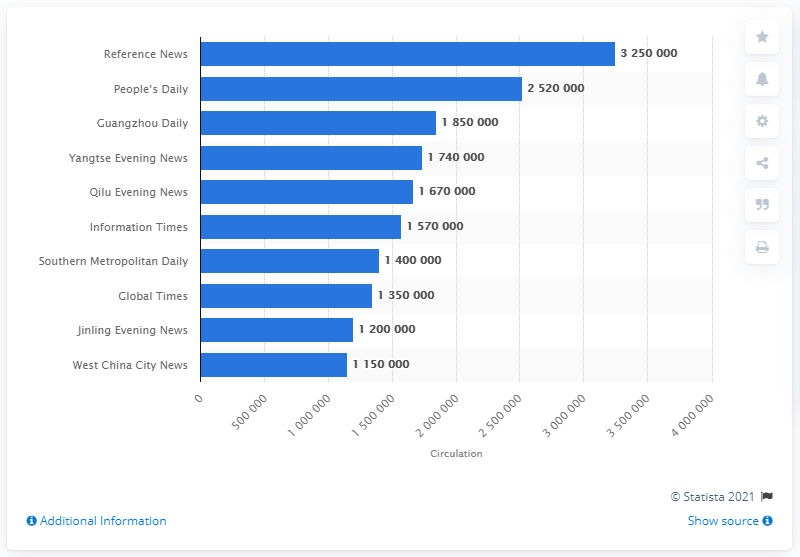Specify some key components in this picture. In 2012, the circulation of "Reference News" was approximately 3250000. 